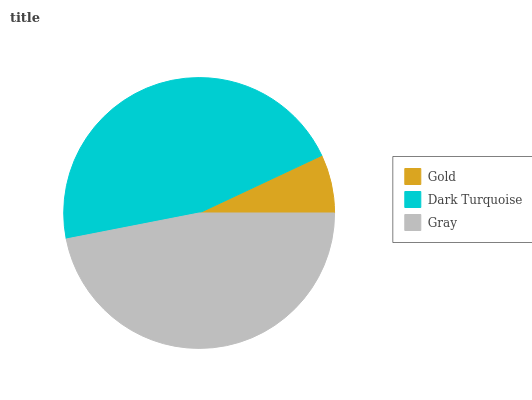Is Gold the minimum?
Answer yes or no. Yes. Is Gray the maximum?
Answer yes or no. Yes. Is Dark Turquoise the minimum?
Answer yes or no. No. Is Dark Turquoise the maximum?
Answer yes or no. No. Is Dark Turquoise greater than Gold?
Answer yes or no. Yes. Is Gold less than Dark Turquoise?
Answer yes or no. Yes. Is Gold greater than Dark Turquoise?
Answer yes or no. No. Is Dark Turquoise less than Gold?
Answer yes or no. No. Is Dark Turquoise the high median?
Answer yes or no. Yes. Is Dark Turquoise the low median?
Answer yes or no. Yes. Is Gold the high median?
Answer yes or no. No. Is Gold the low median?
Answer yes or no. No. 